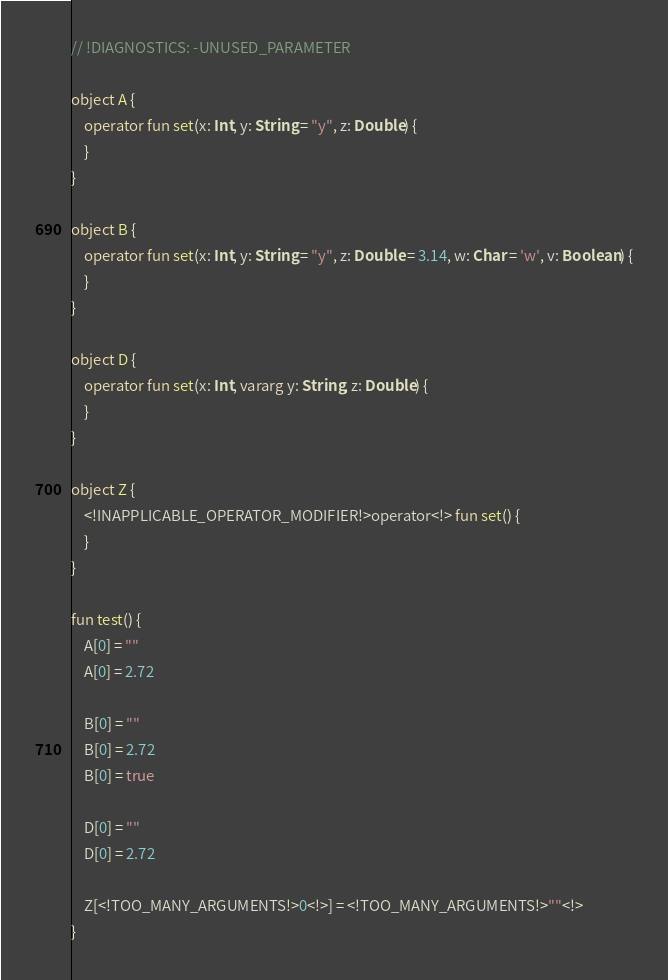<code> <loc_0><loc_0><loc_500><loc_500><_Kotlin_>// !DIAGNOSTICS: -UNUSED_PARAMETER

object A {
    operator fun set(x: Int, y: String = "y", z: Double) {
    }
}

object B {
    operator fun set(x: Int, y: String = "y", z: Double = 3.14, w: Char = 'w', v: Boolean) {
    }
}

object D {
    operator fun set(x: Int, vararg y: String, z: Double) {
    }
}

object Z {
    <!INAPPLICABLE_OPERATOR_MODIFIER!>operator<!> fun set() {
    }
}

fun test() {
    A[0] = ""
    A[0] = 2.72

    B[0] = ""
    B[0] = 2.72
    B[0] = true

    D[0] = ""
    D[0] = 2.72

    Z[<!TOO_MANY_ARGUMENTS!>0<!>] = <!TOO_MANY_ARGUMENTS!>""<!>
}
</code> 